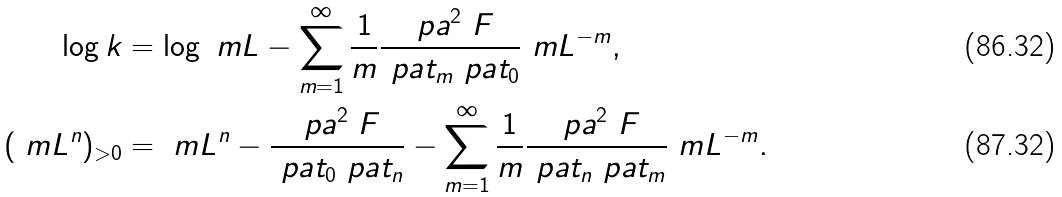<formula> <loc_0><loc_0><loc_500><loc_500>\log k & = \log \ m L - \sum _ { m = 1 } ^ { \infty } \frac { 1 } { m } \frac { \ p a ^ { 2 } \ F } { \ p a t _ { m } \ p a t _ { 0 } } \ m L ^ { - m } , \\ ( \ m L ^ { n } ) _ { > 0 } & = \ m L ^ { n } - \frac { \ p a ^ { 2 } \ F } { \ p a t _ { 0 } \ p a t _ { n } } - \sum _ { m = 1 } ^ { \infty } \frac { 1 } { m } \frac { \ p a ^ { 2 } \ F } { \ p a t _ { n } \ p a t _ { m } } \ m L ^ { - m } .</formula> 